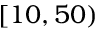<formula> <loc_0><loc_0><loc_500><loc_500>[ 1 0 , 5 0 )</formula> 